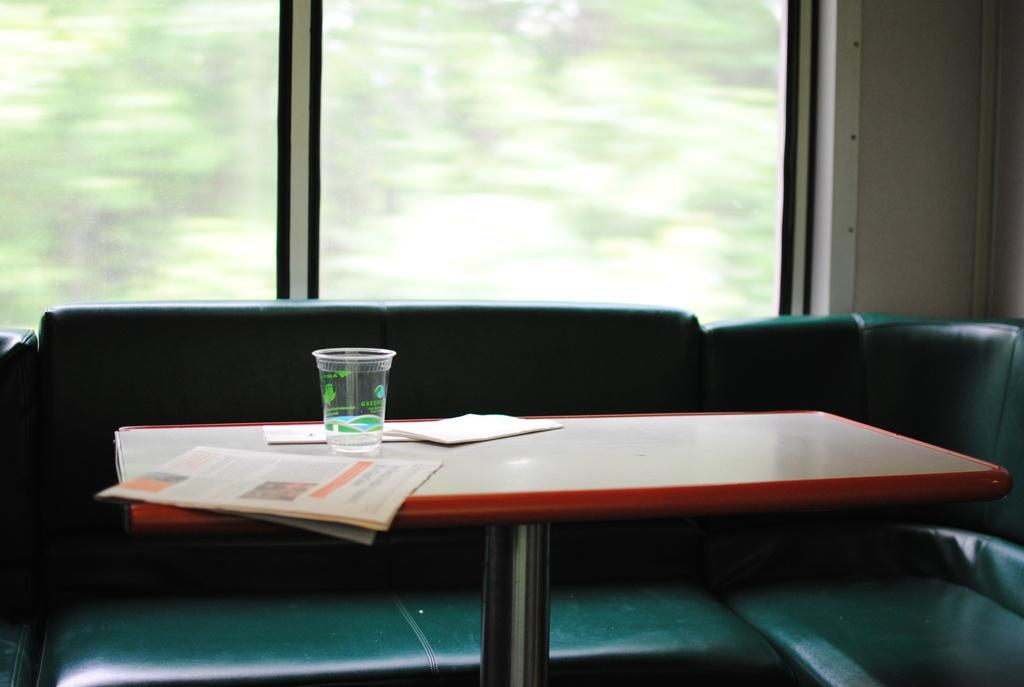What type of furniture is in the image? There is a table in the image. What items are on the table? Newspapers and a glass are present on the table. What is located behind the table? There is a sofa behind the table. What can be seen through the windows behind the sofa? Glass windows are visible behind the sofa. What color is the feather on the table in the image? There is no feather present on the table in the image. How many cherries are on the glass in the image? There are no cherries present on the glass in the image. 